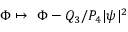Convert formula to latex. <formula><loc_0><loc_0><loc_500><loc_500>\Phi \mapsto \ \Phi - Q _ { 3 } / P _ { 4 } | \psi | ^ { 2 }</formula> 